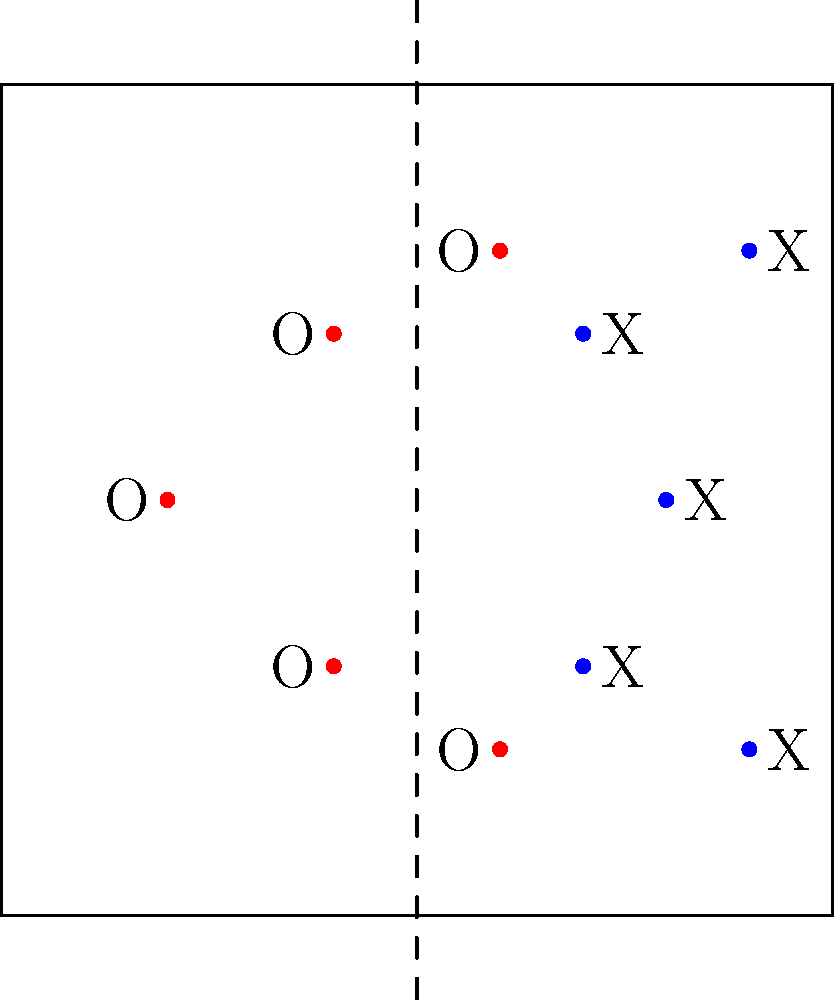Based on the sideline camera angle depicted by the dashed line in the diagram, which defensive coverage scheme is most likely being employed by the defense (X players)? To determine the defensive coverage scheme from the sideline camera angle, we need to analyze the positioning of the defensive players (X) in relation to the offensive players (O). Let's break it down step-by-step:

1. Observe the overall alignment: The defensive players are positioned in a shell-like formation, with three players deeper than the other two.

2. Analyze the positioning of the deep defenders:
   - There is one defender (X) in the middle of the field at depth.
   - Two defenders (X) are positioned wider and deeper, near the sidelines.

3. Look at the positioning of the shorter defenders:
   - Two defenders (X) are positioned closer to the line of scrimmage, across from the inner offensive players.

4. Consider common defensive coverage schemes:
   - Man-to-man coverage typically shows defenders closely aligned with specific offensive players.
   - Zone coverage usually presents a more evenly spaced defensive formation.

5. Evaluate the specific characteristics of this formation:
   - The presence of a single high safety (middle X at depth) is indicative of a single-high safety look.
   - The two deeper defenders near the sidelines suggest they are responsible for deep thirds of the field.
   - The two shorter defenders appear to be responsible for underneath zones.

6. Conclude based on these observations:
   - This formation most closely resembles a Cover 3 zone defense.
   - Cover 3 typically features one deep safety and two cornerbacks each responsible for a deep third of the field, with underneath defenders covering short to intermediate zones.

Given the sideline camera angle and the defensive alignment, the most likely coverage scheme being employed is Cover 3.
Answer: Cover 3 zone defense 